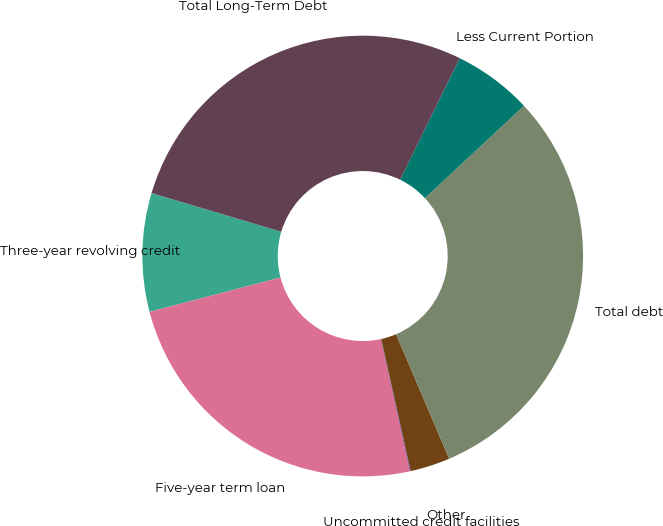Convert chart. <chart><loc_0><loc_0><loc_500><loc_500><pie_chart><fcel>Three-year revolving credit<fcel>Five-year term loan<fcel>Uncommitted credit facilities<fcel>Other<fcel>Total debt<fcel>Less Current Portion<fcel>Total Long-Term Debt<nl><fcel>8.69%<fcel>24.36%<fcel>0.05%<fcel>2.93%<fcel>30.52%<fcel>5.81%<fcel>27.64%<nl></chart> 